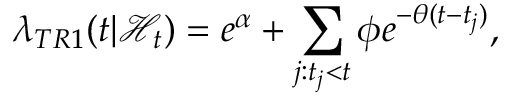<formula> <loc_0><loc_0><loc_500><loc_500>\lambda _ { T R 1 } ( t | \mathcal { H } _ { t } ) = e ^ { \alpha } + \sum _ { j \colon t _ { j } < t } \phi e ^ { - \theta ( t - t _ { j } ) } ,</formula> 